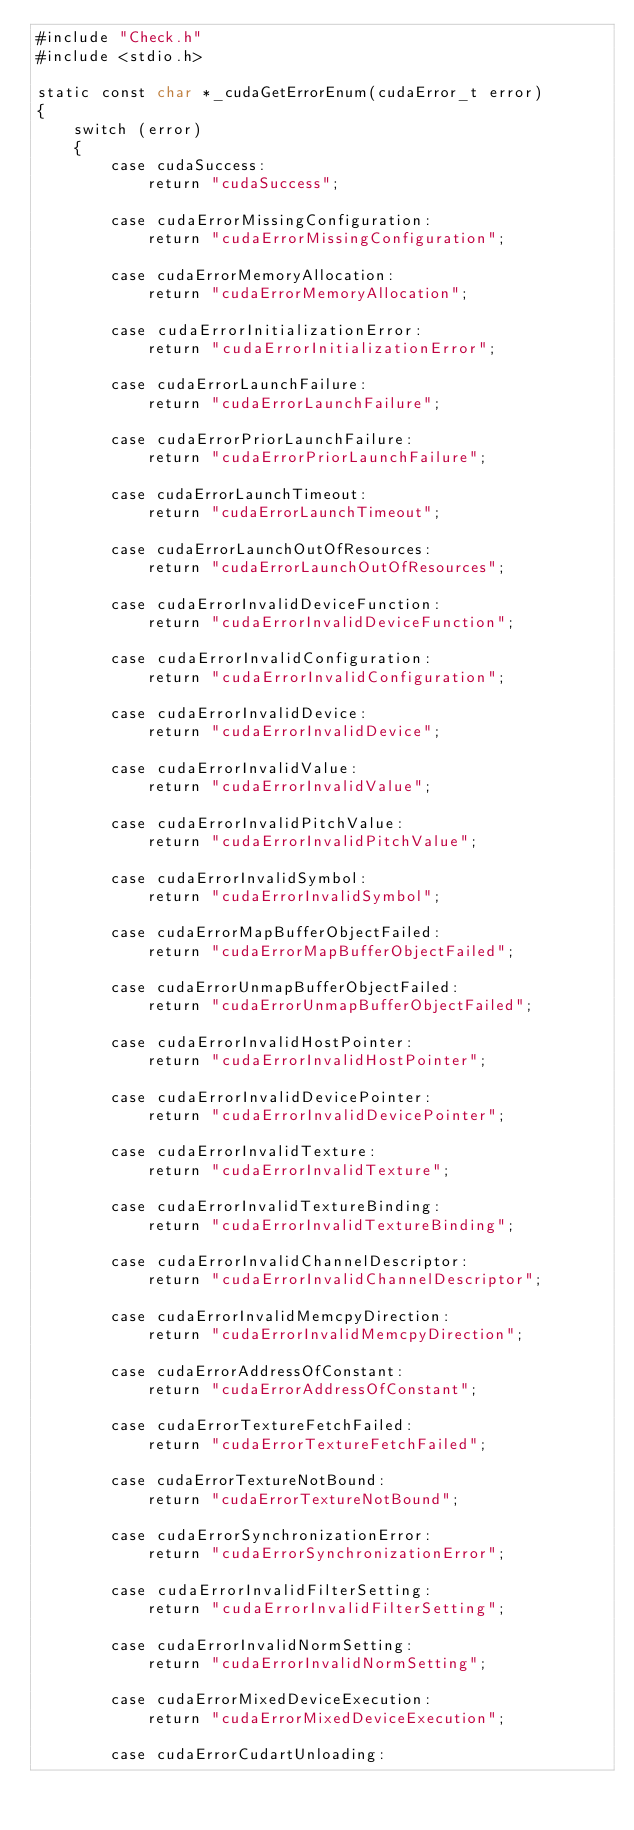Convert code to text. <code><loc_0><loc_0><loc_500><loc_500><_Cuda_>#include "Check.h"
#include <stdio.h>

static const char *_cudaGetErrorEnum(cudaError_t error)
{
    switch (error)
    {
        case cudaSuccess:
            return "cudaSuccess";

        case cudaErrorMissingConfiguration:
            return "cudaErrorMissingConfiguration";

        case cudaErrorMemoryAllocation:
            return "cudaErrorMemoryAllocation";

        case cudaErrorInitializationError:
            return "cudaErrorInitializationError";

        case cudaErrorLaunchFailure:
            return "cudaErrorLaunchFailure";

        case cudaErrorPriorLaunchFailure:
            return "cudaErrorPriorLaunchFailure";

        case cudaErrorLaunchTimeout:
            return "cudaErrorLaunchTimeout";

        case cudaErrorLaunchOutOfResources:
            return "cudaErrorLaunchOutOfResources";

        case cudaErrorInvalidDeviceFunction:
            return "cudaErrorInvalidDeviceFunction";

        case cudaErrorInvalidConfiguration:
            return "cudaErrorInvalidConfiguration";

        case cudaErrorInvalidDevice:
            return "cudaErrorInvalidDevice";

        case cudaErrorInvalidValue:
            return "cudaErrorInvalidValue";

        case cudaErrorInvalidPitchValue:
            return "cudaErrorInvalidPitchValue";

        case cudaErrorInvalidSymbol:
            return "cudaErrorInvalidSymbol";

        case cudaErrorMapBufferObjectFailed:
            return "cudaErrorMapBufferObjectFailed";

        case cudaErrorUnmapBufferObjectFailed:
            return "cudaErrorUnmapBufferObjectFailed";

        case cudaErrorInvalidHostPointer:
            return "cudaErrorInvalidHostPointer";

        case cudaErrorInvalidDevicePointer:
            return "cudaErrorInvalidDevicePointer";

        case cudaErrorInvalidTexture:
            return "cudaErrorInvalidTexture";

        case cudaErrorInvalidTextureBinding:
            return "cudaErrorInvalidTextureBinding";

        case cudaErrorInvalidChannelDescriptor:
            return "cudaErrorInvalidChannelDescriptor";

        case cudaErrorInvalidMemcpyDirection:
            return "cudaErrorInvalidMemcpyDirection";

        case cudaErrorAddressOfConstant:
            return "cudaErrorAddressOfConstant";

        case cudaErrorTextureFetchFailed:
            return "cudaErrorTextureFetchFailed";

        case cudaErrorTextureNotBound:
            return "cudaErrorTextureNotBound";

        case cudaErrorSynchronizationError:
            return "cudaErrorSynchronizationError";

        case cudaErrorInvalidFilterSetting:
            return "cudaErrorInvalidFilterSetting";

        case cudaErrorInvalidNormSetting:
            return "cudaErrorInvalidNormSetting";

        case cudaErrorMixedDeviceExecution:
            return "cudaErrorMixedDeviceExecution";

        case cudaErrorCudartUnloading:</code> 